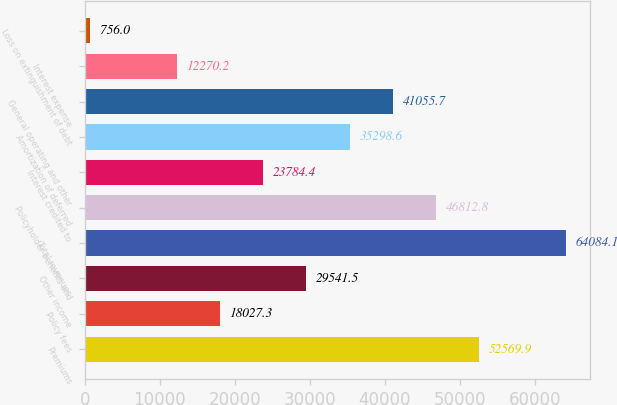Convert chart. <chart><loc_0><loc_0><loc_500><loc_500><bar_chart><fcel>Premiums<fcel>Policy fees<fcel>Other income<fcel>Total revenues<fcel>Policyholder benefits and<fcel>Interest credited to<fcel>Amortization of deferred<fcel>General operating and other<fcel>Interest expense<fcel>Loss on extinguishment of debt<nl><fcel>52569.9<fcel>18027.3<fcel>29541.5<fcel>64084.1<fcel>46812.8<fcel>23784.4<fcel>35298.6<fcel>41055.7<fcel>12270.2<fcel>756<nl></chart> 